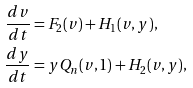Convert formula to latex. <formula><loc_0><loc_0><loc_500><loc_500>\frac { d v } { d t } & = F _ { 2 } ( v ) + H _ { 1 } ( v , y ) , \\ \frac { d y } { d t } & = y Q _ { n } ( v , 1 ) + H _ { 2 } ( v , y ) ,</formula> 